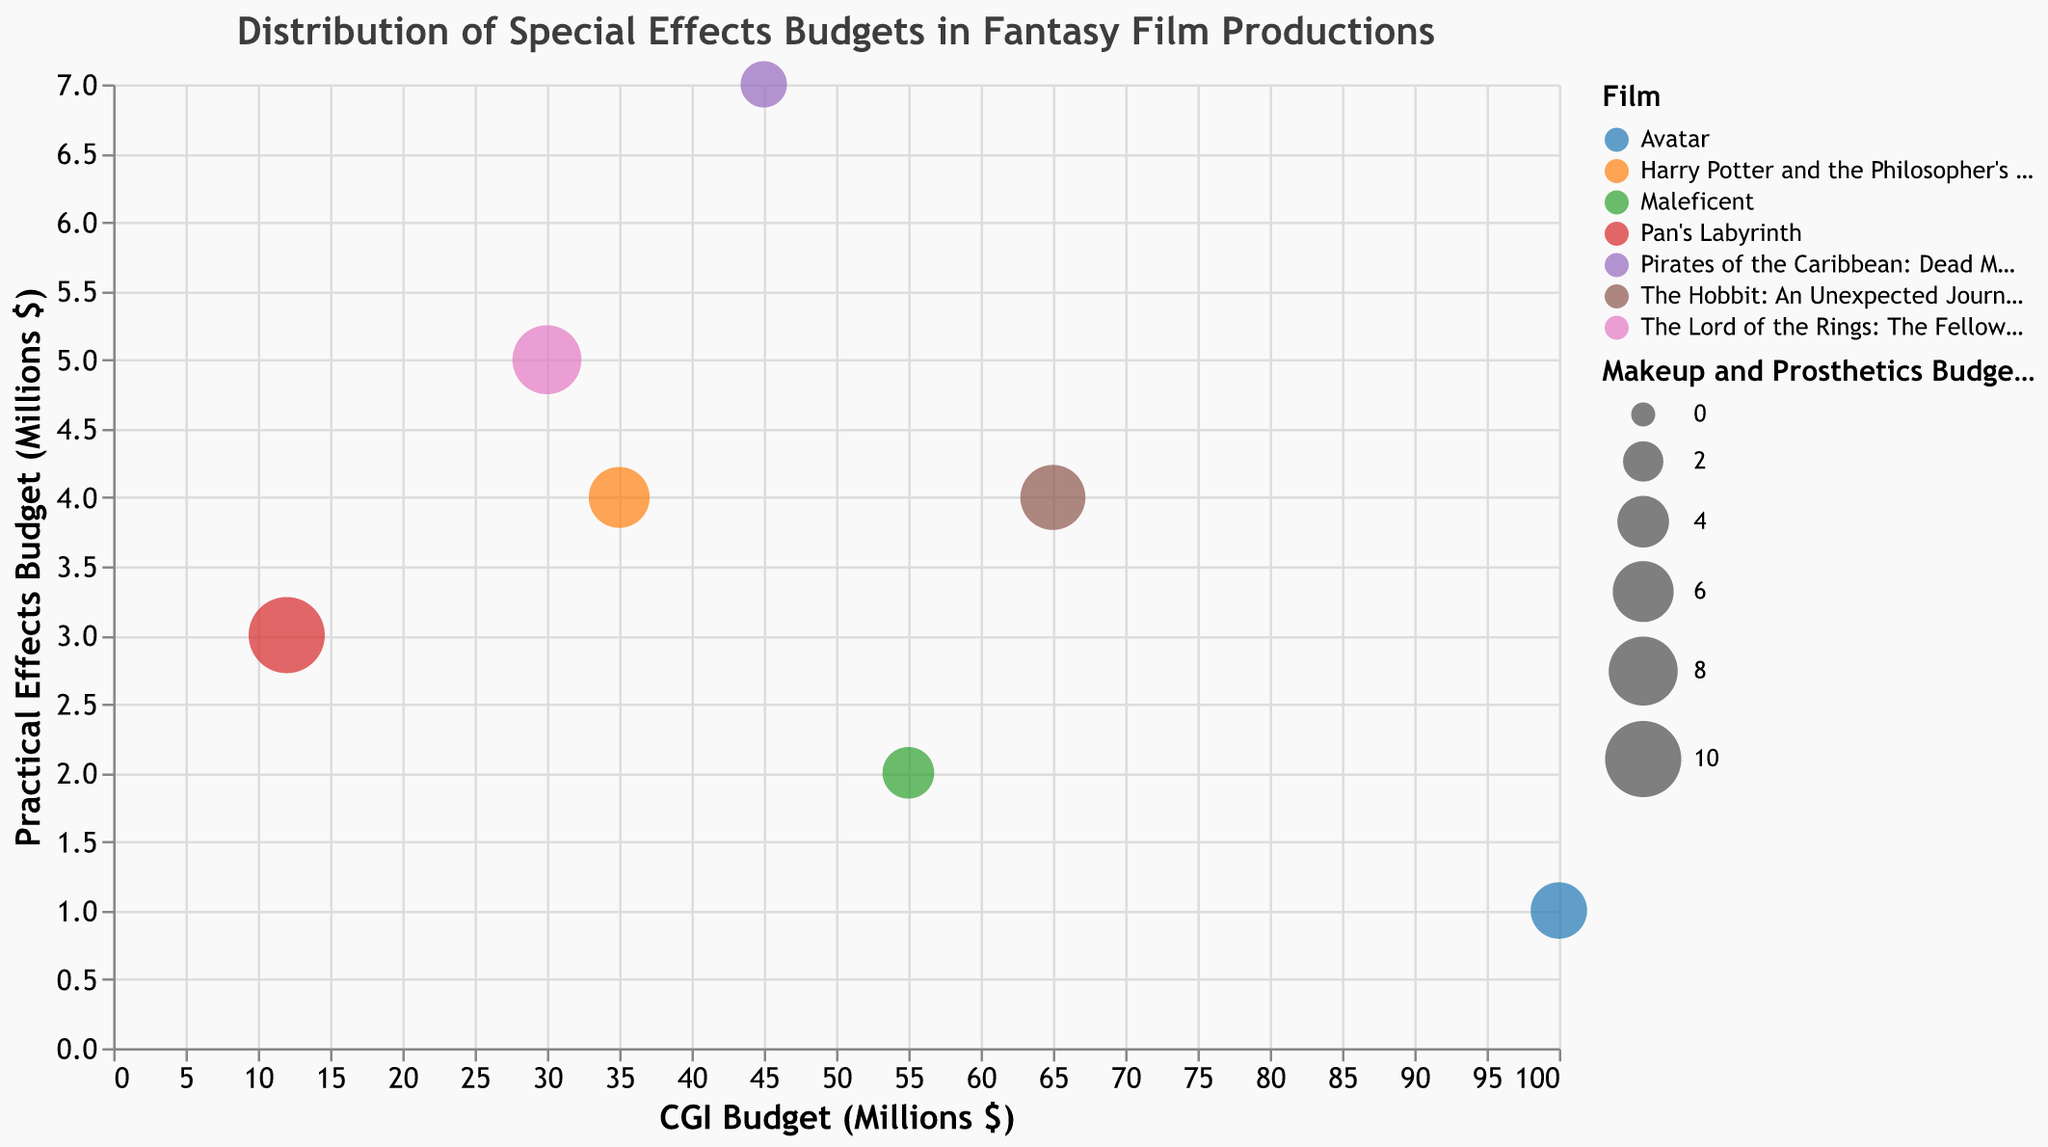How many films are represented in the chart? Count the number of distinct bubbles present on the chart, each representing a unique film. There are 7 films.
Answer: 7 What is the title of the chart? The title of the chart is displayed at the top of the figure. It reads "Distribution of Special Effects Budgets in Fantasy Film Productions".
Answer: Distribution of Special Effects Budgets in Fantasy Film Productions Which film has the largest Makeup and Prosthetics Budget? Look for the largest bubble on the chart since the size of the bubble represents the Makeup and Prosthetics Budget. The largest bubble corresponds to "Pan's Labyrinth".
Answer: Pan's Labyrinth Which film has the lowest practical effects budget and how much is it? Find the bubble closest to the bottom of the chart. Hover over it to get the tooltip information. "Avatar" has the lowest practical effects budget at $1 million.
Answer: Avatar, $1 million How does the CGI Budget of "The Hobbit: An Unexpected Journey" compare to "Maleficent"? Locate the bubbles for both films and check their horizontal positions. "The Hobbit: An Unexpected Journey" is further to the right indicating it has a higher CGI budget. "The Hobbit" has $65 million and "Maleficent" has $55 million.
Answer: The Hobbit: An Unexpected Journey has a higher CGI Budget What is the average CGI Budget of all the films? Sum all the CGI Budgets and divide by the number of films: (30 + 35 + 12 + 100 + 65 + 55 + 45) = 342. The number of films is 7. So, 342 / 7 = 48.86 million.
Answer: $48.86 million Which film has the highest practical effects budget and how much is it? Find the bubble closest to the top of the chart. Hover over it to get the tooltip information. "Pirates of the Caribbean: Dead Man's Chest" has the highest practical effects budget at $7 million.
Answer: Pirates of the Caribbean: Dead Man's Chest, $7 million What is the total Makeup and Prosthetics Budget for "The Lord of the Rings: The Fellowship of the Ring" and "Harry Potter and the Philosopher's Stone"? Find the bubbles for both films and note their sizes. Add their Makeup and Prosthetics Budgets: 8 million + 6 million = 14 million.
Answer: $14 million Which film has a CGI Budget significantly higher than its Practical Effects Budget? Compare the horizontal (CGI Budget) and vertical (Practical Effects Budget) positions of each bubble. "Avatar" has a CGI Budget of $100 million far surpassing its Practical Effects Budget of $1 million.
Answer: Avatar 